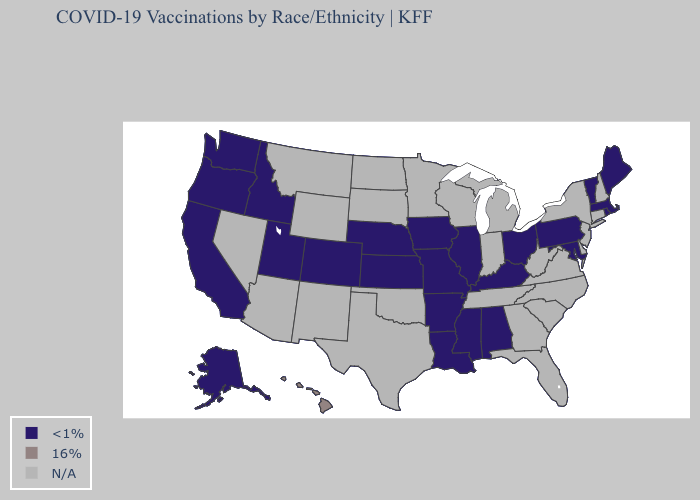What is the value of Tennessee?
Give a very brief answer. N/A. Among the states that border South Dakota , which have the lowest value?
Quick response, please. Iowa, Nebraska. What is the value of Florida?
Keep it brief. N/A. Is the legend a continuous bar?
Short answer required. No. What is the lowest value in states that border Connecticut?
Quick response, please. <1%. What is the value of Alaska?
Write a very short answer. <1%. Name the states that have a value in the range 16%?
Concise answer only. Hawaii. Name the states that have a value in the range N/A?
Concise answer only. Arizona, Connecticut, Delaware, Florida, Georgia, Indiana, Michigan, Minnesota, Montana, Nevada, New Hampshire, New Jersey, New Mexico, New York, North Carolina, North Dakota, Oklahoma, South Carolina, South Dakota, Tennessee, Texas, Virginia, West Virginia, Wisconsin, Wyoming. What is the value of Connecticut?
Answer briefly. N/A. Does Hawaii have the highest value in the USA?
Give a very brief answer. Yes. Name the states that have a value in the range 16%?
Write a very short answer. Hawaii. What is the lowest value in states that border Minnesota?
Concise answer only. <1%. What is the value of Georgia?
Keep it brief. N/A. 